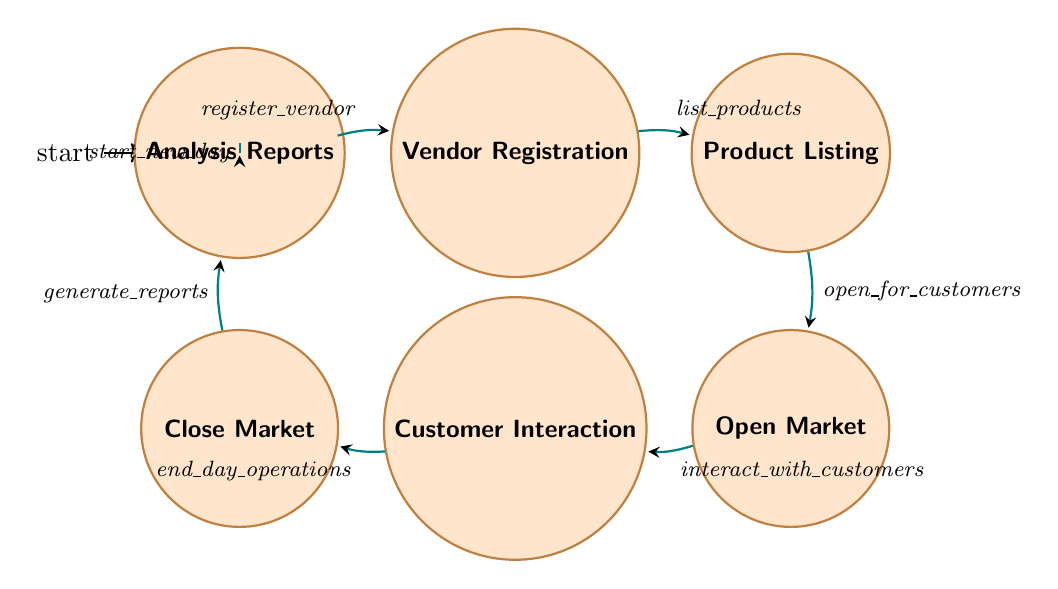What is the first state in the diagram? The first state in the diagram is the "Start" state, which is where operations begin.
Answer: Start How many nodes are there in total? The diagram shows a total of seven nodes representing different stages of the local market operations.
Answer: Seven What is the transition between "Close Market" and "Analysis Reports"? The transition between "Close Market" and "Analysis Reports" is labeled "generate_reports," indicating that reports are generated after closing the market.
Answer: generate_reports What action leads to the "Open Market" state? The action that leads to the "Open Market" state is "open_for_customers," highlighting the step where the market becomes accessible to customers.
Answer: open_for_customers Which state follows "Customer Interaction"? The state that follows "Customer Interaction" is "Close Market," indicating that after interaction with customers, the market operations end for the day.
Answer: Close Market After analyzing reports, what is the next action? After analyzing reports, the next action is "start_new_day," which loops back to the "Start" state to begin the next day of operations.
Answer: start_new_day Which state involves vendors registering their businesses? The state where vendors register their businesses is "Vendor Registration," where they officially sign up for participation in the local market.
Answer: Vendor Registration What is the relationship between "Product Listing" and "Open Market"? The relationship is that vendors must first complete "Product Listing" in order to transition to "Open Market"; hence, the flow follows that order.
Answer: Product Listing → Open Market What is the last state of the operation process before generating reports? The last state before generating reports is "Close Market," where the market concludes its operations for the day.
Answer: Close Market 